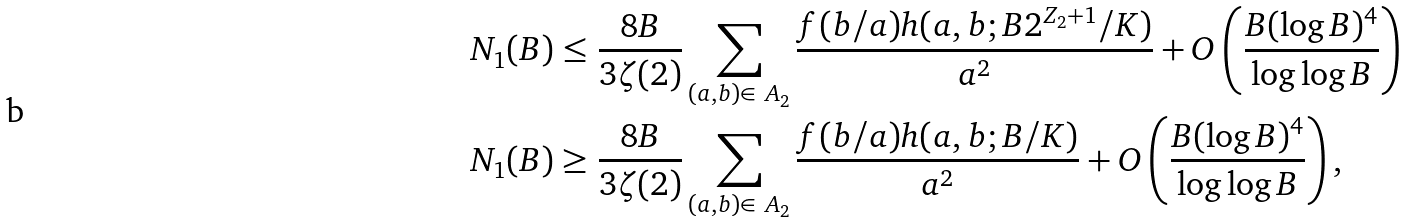Convert formula to latex. <formula><loc_0><loc_0><loc_500><loc_500>N _ { 1 } ( B ) & \leq \frac { 8 B } { 3 \zeta ( 2 ) } \sum _ { ( a , b ) \in \ A _ { 2 } } \frac { f ( b / a ) h ( a , b ; B 2 ^ { Z _ { 2 } + 1 } / K ) } { a ^ { 2 } } + O \left ( \frac { B ( \log B ) ^ { 4 } } { \log \log B } \right ) \\ N _ { 1 } ( B ) & \geq \frac { 8 B } { 3 \zeta ( 2 ) } \sum _ { ( a , b ) \in \ A _ { 2 } } \frac { f ( b / a ) h ( a , b ; B / K ) } { a ^ { 2 } } + O \left ( \frac { B ( \log B ) ^ { 4 } } { \log \log B } \right ) ,</formula> 